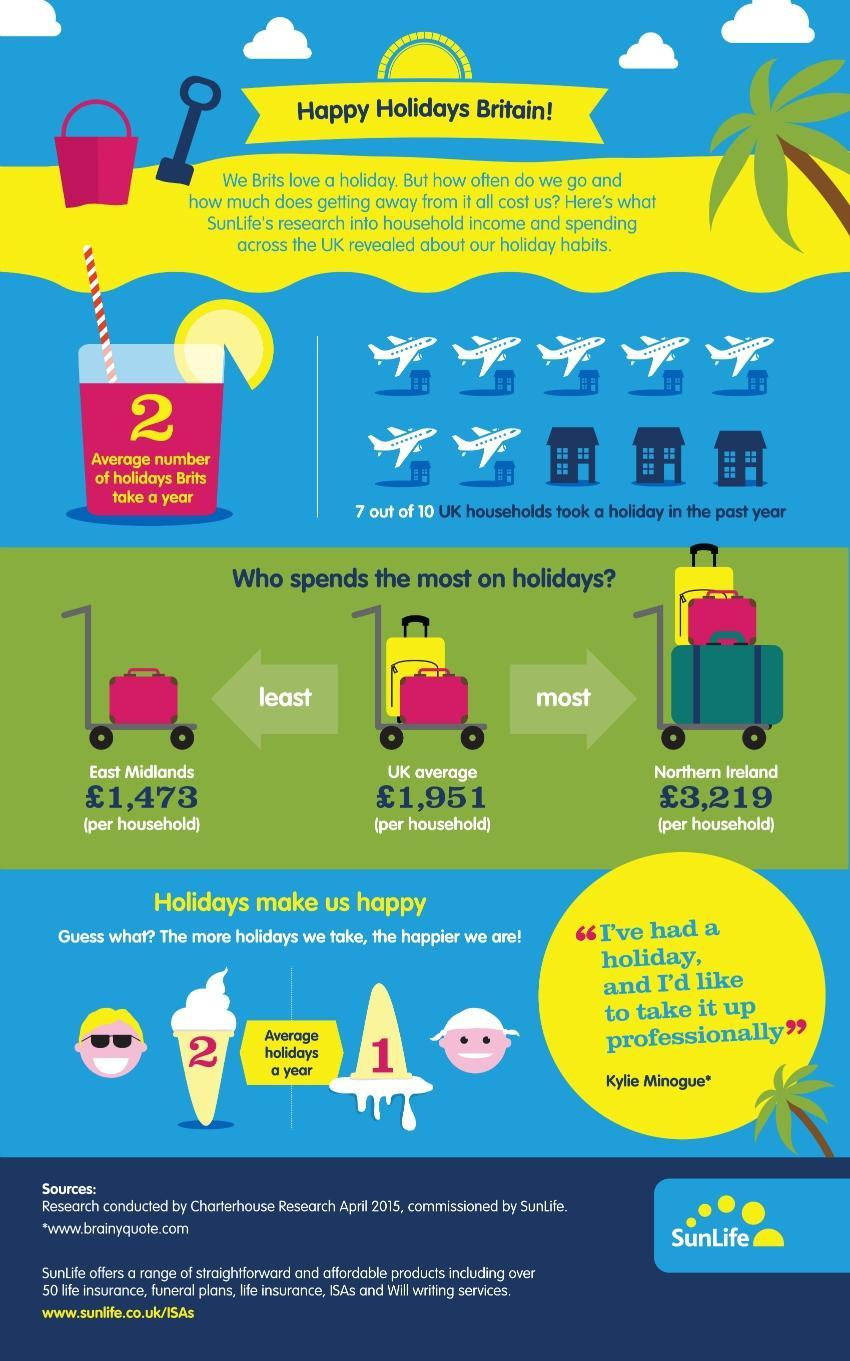What is the average money spend per household on holidays in UK?
Answer the question with a short phrase. £1,951 Which region in UK spend least money on holidays? East Midlands Which country in UK spend most of the money on holidays? Northern Ireland How much money is spend per household on holidays in Northern Ireland? £3,219 